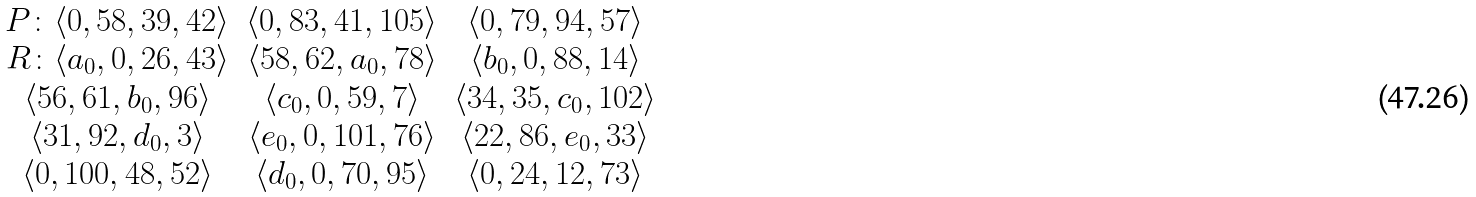<formula> <loc_0><loc_0><loc_500><loc_500>\begin{array} { c c c } P \colon \langle 0 , 5 8 , 3 9 , 4 2 \rangle & \langle 0 , 8 3 , 4 1 , 1 0 5 \rangle & \langle 0 , 7 9 , 9 4 , 5 7 \rangle \\ R \colon \langle a _ { 0 } , 0 , 2 6 , 4 3 \rangle & \langle 5 8 , 6 2 , a _ { 0 } , 7 8 \rangle & \langle b _ { 0 } , 0 , 8 8 , 1 4 \rangle \\ \langle 5 6 , 6 1 , b _ { 0 } , 9 6 \rangle & \langle c _ { 0 } , 0 , 5 9 , 7 \rangle & \langle 3 4 , 3 5 , c _ { 0 } , 1 0 2 \rangle \\ \langle 3 1 , 9 2 , d _ { 0 } , 3 \rangle & \langle e _ { 0 } , 0 , 1 0 1 , 7 6 \rangle & \langle 2 2 , 8 6 , e _ { 0 } , 3 3 \rangle \\ \langle 0 , 1 0 0 , 4 8 , 5 2 \rangle & \langle d _ { 0 } , 0 , 7 0 , 9 5 \rangle & \langle 0 , 2 4 , 1 2 , 7 3 \rangle \\ \end{array}</formula> 